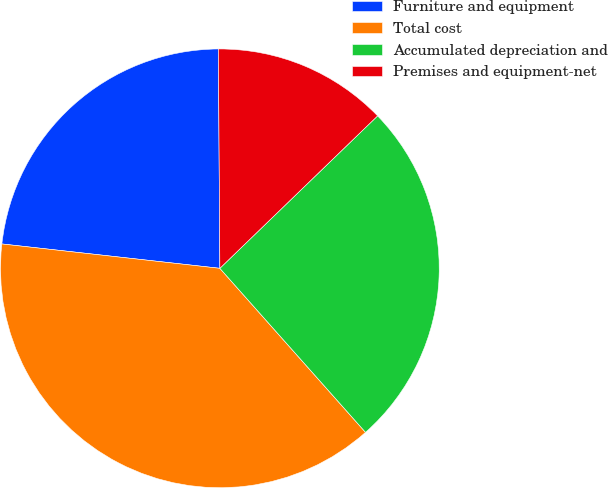Convert chart to OTSL. <chart><loc_0><loc_0><loc_500><loc_500><pie_chart><fcel>Furniture and equipment<fcel>Total cost<fcel>Accumulated depreciation and<fcel>Premises and equipment-net<nl><fcel>23.12%<fcel>38.33%<fcel>25.67%<fcel>12.88%<nl></chart> 